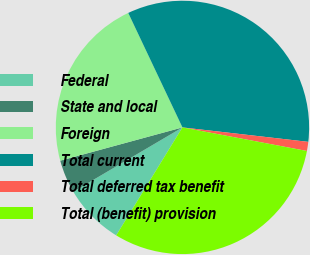Convert chart to OTSL. <chart><loc_0><loc_0><loc_500><loc_500><pie_chart><fcel>Federal<fcel>State and local<fcel>Foreign<fcel>Total current<fcel>Total deferred tax benefit<fcel>Total (benefit) provision<nl><fcel>7.77%<fcel>4.24%<fcel>22.19%<fcel>33.86%<fcel>1.16%<fcel>30.78%<nl></chart> 